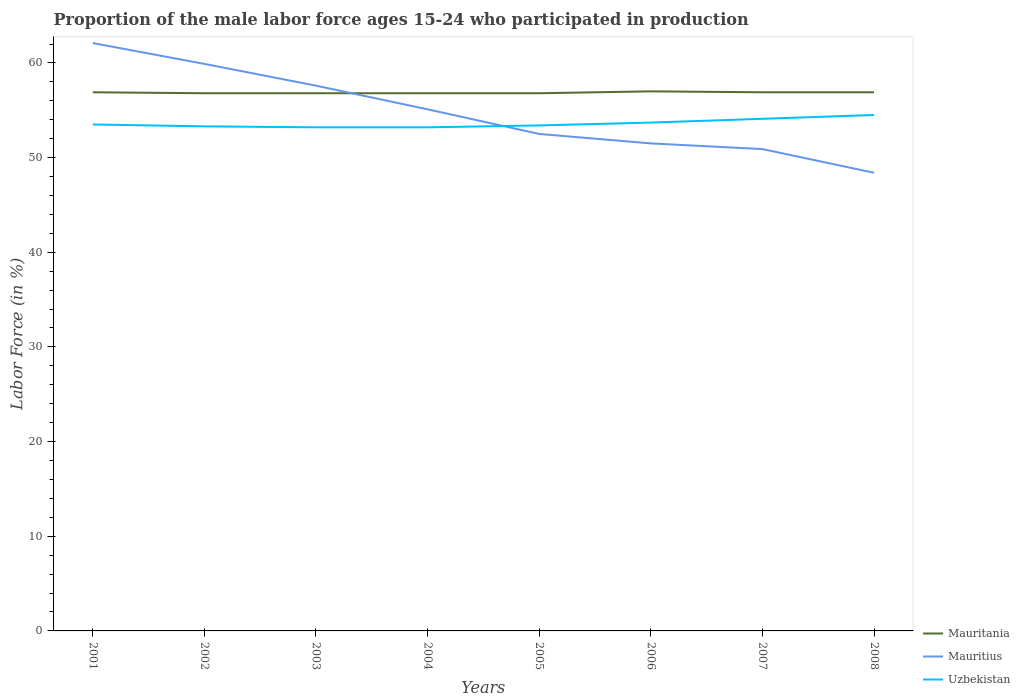How many different coloured lines are there?
Give a very brief answer. 3. Across all years, what is the maximum proportion of the male labor force who participated in production in Mauritania?
Your response must be concise. 56.8. What is the difference between the highest and the second highest proportion of the male labor force who participated in production in Mauritius?
Your answer should be compact. 13.7. How many years are there in the graph?
Give a very brief answer. 8. What is the difference between two consecutive major ticks on the Y-axis?
Offer a terse response. 10. Are the values on the major ticks of Y-axis written in scientific E-notation?
Your response must be concise. No. Does the graph contain any zero values?
Ensure brevity in your answer.  No. Where does the legend appear in the graph?
Keep it short and to the point. Bottom right. What is the title of the graph?
Provide a short and direct response. Proportion of the male labor force ages 15-24 who participated in production. Does "Liechtenstein" appear as one of the legend labels in the graph?
Offer a terse response. No. What is the label or title of the Y-axis?
Ensure brevity in your answer.  Labor Force (in %). What is the Labor Force (in %) of Mauritania in 2001?
Give a very brief answer. 56.9. What is the Labor Force (in %) of Mauritius in 2001?
Give a very brief answer. 62.1. What is the Labor Force (in %) in Uzbekistan in 2001?
Give a very brief answer. 53.5. What is the Labor Force (in %) of Mauritania in 2002?
Provide a succinct answer. 56.8. What is the Labor Force (in %) in Mauritius in 2002?
Your answer should be very brief. 59.9. What is the Labor Force (in %) of Uzbekistan in 2002?
Your answer should be compact. 53.3. What is the Labor Force (in %) of Mauritania in 2003?
Provide a short and direct response. 56.8. What is the Labor Force (in %) in Mauritius in 2003?
Your answer should be very brief. 57.6. What is the Labor Force (in %) of Uzbekistan in 2003?
Offer a terse response. 53.2. What is the Labor Force (in %) in Mauritania in 2004?
Provide a succinct answer. 56.8. What is the Labor Force (in %) of Mauritius in 2004?
Provide a short and direct response. 55.1. What is the Labor Force (in %) in Uzbekistan in 2004?
Your answer should be very brief. 53.2. What is the Labor Force (in %) in Mauritania in 2005?
Give a very brief answer. 56.8. What is the Labor Force (in %) of Mauritius in 2005?
Keep it short and to the point. 52.5. What is the Labor Force (in %) in Uzbekistan in 2005?
Give a very brief answer. 53.4. What is the Labor Force (in %) of Mauritania in 2006?
Ensure brevity in your answer.  57. What is the Labor Force (in %) in Mauritius in 2006?
Provide a succinct answer. 51.5. What is the Labor Force (in %) of Uzbekistan in 2006?
Ensure brevity in your answer.  53.7. What is the Labor Force (in %) of Mauritania in 2007?
Your answer should be very brief. 56.9. What is the Labor Force (in %) of Mauritius in 2007?
Keep it short and to the point. 50.9. What is the Labor Force (in %) in Uzbekistan in 2007?
Provide a succinct answer. 54.1. What is the Labor Force (in %) in Mauritania in 2008?
Offer a terse response. 56.9. What is the Labor Force (in %) in Mauritius in 2008?
Ensure brevity in your answer.  48.4. What is the Labor Force (in %) of Uzbekistan in 2008?
Provide a short and direct response. 54.5. Across all years, what is the maximum Labor Force (in %) of Mauritania?
Offer a very short reply. 57. Across all years, what is the maximum Labor Force (in %) of Mauritius?
Offer a terse response. 62.1. Across all years, what is the maximum Labor Force (in %) of Uzbekistan?
Keep it short and to the point. 54.5. Across all years, what is the minimum Labor Force (in %) in Mauritania?
Ensure brevity in your answer.  56.8. Across all years, what is the minimum Labor Force (in %) in Mauritius?
Your answer should be compact. 48.4. Across all years, what is the minimum Labor Force (in %) of Uzbekistan?
Provide a succinct answer. 53.2. What is the total Labor Force (in %) in Mauritania in the graph?
Provide a short and direct response. 454.9. What is the total Labor Force (in %) of Mauritius in the graph?
Offer a terse response. 438. What is the total Labor Force (in %) in Uzbekistan in the graph?
Your answer should be very brief. 428.9. What is the difference between the Labor Force (in %) of Mauritania in 2001 and that in 2002?
Your response must be concise. 0.1. What is the difference between the Labor Force (in %) in Mauritius in 2001 and that in 2002?
Offer a very short reply. 2.2. What is the difference between the Labor Force (in %) in Mauritania in 2001 and that in 2003?
Your response must be concise. 0.1. What is the difference between the Labor Force (in %) in Mauritius in 2001 and that in 2003?
Ensure brevity in your answer.  4.5. What is the difference between the Labor Force (in %) of Mauritania in 2001 and that in 2004?
Your answer should be very brief. 0.1. What is the difference between the Labor Force (in %) in Uzbekistan in 2001 and that in 2004?
Give a very brief answer. 0.3. What is the difference between the Labor Force (in %) of Mauritius in 2001 and that in 2006?
Provide a short and direct response. 10.6. What is the difference between the Labor Force (in %) of Mauritania in 2001 and that in 2007?
Offer a very short reply. 0. What is the difference between the Labor Force (in %) of Mauritania in 2001 and that in 2008?
Offer a very short reply. 0. What is the difference between the Labor Force (in %) in Uzbekistan in 2001 and that in 2008?
Your response must be concise. -1. What is the difference between the Labor Force (in %) of Mauritania in 2002 and that in 2003?
Ensure brevity in your answer.  0. What is the difference between the Labor Force (in %) of Uzbekistan in 2002 and that in 2003?
Keep it short and to the point. 0.1. What is the difference between the Labor Force (in %) of Mauritius in 2002 and that in 2004?
Keep it short and to the point. 4.8. What is the difference between the Labor Force (in %) of Uzbekistan in 2002 and that in 2004?
Offer a very short reply. 0.1. What is the difference between the Labor Force (in %) in Mauritania in 2002 and that in 2006?
Your answer should be very brief. -0.2. What is the difference between the Labor Force (in %) of Mauritius in 2002 and that in 2007?
Give a very brief answer. 9. What is the difference between the Labor Force (in %) in Mauritania in 2002 and that in 2008?
Your answer should be very brief. -0.1. What is the difference between the Labor Force (in %) of Mauritius in 2002 and that in 2008?
Offer a very short reply. 11.5. What is the difference between the Labor Force (in %) of Uzbekistan in 2002 and that in 2008?
Your response must be concise. -1.2. What is the difference between the Labor Force (in %) in Mauritania in 2003 and that in 2005?
Keep it short and to the point. 0. What is the difference between the Labor Force (in %) in Mauritius in 2003 and that in 2005?
Provide a short and direct response. 5.1. What is the difference between the Labor Force (in %) of Uzbekistan in 2003 and that in 2005?
Your response must be concise. -0.2. What is the difference between the Labor Force (in %) in Mauritius in 2003 and that in 2006?
Give a very brief answer. 6.1. What is the difference between the Labor Force (in %) of Uzbekistan in 2003 and that in 2006?
Make the answer very short. -0.5. What is the difference between the Labor Force (in %) in Mauritania in 2003 and that in 2007?
Give a very brief answer. -0.1. What is the difference between the Labor Force (in %) in Uzbekistan in 2003 and that in 2007?
Make the answer very short. -0.9. What is the difference between the Labor Force (in %) in Mauritius in 2003 and that in 2008?
Make the answer very short. 9.2. What is the difference between the Labor Force (in %) of Uzbekistan in 2003 and that in 2008?
Keep it short and to the point. -1.3. What is the difference between the Labor Force (in %) of Mauritania in 2004 and that in 2006?
Your answer should be very brief. -0.2. What is the difference between the Labor Force (in %) of Mauritius in 2004 and that in 2006?
Keep it short and to the point. 3.6. What is the difference between the Labor Force (in %) of Uzbekistan in 2004 and that in 2006?
Make the answer very short. -0.5. What is the difference between the Labor Force (in %) of Mauritius in 2004 and that in 2007?
Offer a very short reply. 4.2. What is the difference between the Labor Force (in %) of Mauritania in 2004 and that in 2008?
Offer a very short reply. -0.1. What is the difference between the Labor Force (in %) in Uzbekistan in 2004 and that in 2008?
Your answer should be very brief. -1.3. What is the difference between the Labor Force (in %) in Mauritius in 2005 and that in 2006?
Make the answer very short. 1. What is the difference between the Labor Force (in %) of Uzbekistan in 2005 and that in 2006?
Offer a terse response. -0.3. What is the difference between the Labor Force (in %) of Mauritius in 2005 and that in 2007?
Provide a succinct answer. 1.6. What is the difference between the Labor Force (in %) of Uzbekistan in 2005 and that in 2007?
Your answer should be very brief. -0.7. What is the difference between the Labor Force (in %) of Mauritania in 2005 and that in 2008?
Keep it short and to the point. -0.1. What is the difference between the Labor Force (in %) of Uzbekistan in 2005 and that in 2008?
Make the answer very short. -1.1. What is the difference between the Labor Force (in %) of Mauritius in 2006 and that in 2007?
Offer a very short reply. 0.6. What is the difference between the Labor Force (in %) in Uzbekistan in 2006 and that in 2007?
Your answer should be compact. -0.4. What is the difference between the Labor Force (in %) in Mauritius in 2006 and that in 2008?
Your response must be concise. 3.1. What is the difference between the Labor Force (in %) of Mauritius in 2007 and that in 2008?
Your response must be concise. 2.5. What is the difference between the Labor Force (in %) of Uzbekistan in 2007 and that in 2008?
Provide a short and direct response. -0.4. What is the difference between the Labor Force (in %) in Mauritania in 2001 and the Labor Force (in %) in Mauritius in 2002?
Offer a terse response. -3. What is the difference between the Labor Force (in %) in Mauritania in 2001 and the Labor Force (in %) in Uzbekistan in 2003?
Make the answer very short. 3.7. What is the difference between the Labor Force (in %) in Mauritius in 2001 and the Labor Force (in %) in Uzbekistan in 2003?
Offer a terse response. 8.9. What is the difference between the Labor Force (in %) of Mauritania in 2001 and the Labor Force (in %) of Mauritius in 2004?
Make the answer very short. 1.8. What is the difference between the Labor Force (in %) of Mauritius in 2001 and the Labor Force (in %) of Uzbekistan in 2004?
Your response must be concise. 8.9. What is the difference between the Labor Force (in %) of Mauritania in 2001 and the Labor Force (in %) of Mauritius in 2005?
Give a very brief answer. 4.4. What is the difference between the Labor Force (in %) in Mauritius in 2001 and the Labor Force (in %) in Uzbekistan in 2005?
Make the answer very short. 8.7. What is the difference between the Labor Force (in %) of Mauritania in 2001 and the Labor Force (in %) of Mauritius in 2006?
Make the answer very short. 5.4. What is the difference between the Labor Force (in %) in Mauritania in 2001 and the Labor Force (in %) in Uzbekistan in 2006?
Your response must be concise. 3.2. What is the difference between the Labor Force (in %) of Mauritius in 2001 and the Labor Force (in %) of Uzbekistan in 2007?
Offer a terse response. 8. What is the difference between the Labor Force (in %) of Mauritania in 2001 and the Labor Force (in %) of Mauritius in 2008?
Keep it short and to the point. 8.5. What is the difference between the Labor Force (in %) in Mauritania in 2002 and the Labor Force (in %) in Mauritius in 2003?
Your response must be concise. -0.8. What is the difference between the Labor Force (in %) of Mauritania in 2002 and the Labor Force (in %) of Uzbekistan in 2003?
Provide a succinct answer. 3.6. What is the difference between the Labor Force (in %) of Mauritius in 2002 and the Labor Force (in %) of Uzbekistan in 2003?
Make the answer very short. 6.7. What is the difference between the Labor Force (in %) of Mauritania in 2002 and the Labor Force (in %) of Mauritius in 2004?
Your answer should be very brief. 1.7. What is the difference between the Labor Force (in %) of Mauritania in 2002 and the Labor Force (in %) of Mauritius in 2005?
Provide a succinct answer. 4.3. What is the difference between the Labor Force (in %) of Mauritania in 2002 and the Labor Force (in %) of Uzbekistan in 2005?
Your answer should be very brief. 3.4. What is the difference between the Labor Force (in %) of Mauritius in 2002 and the Labor Force (in %) of Uzbekistan in 2005?
Your response must be concise. 6.5. What is the difference between the Labor Force (in %) of Mauritania in 2002 and the Labor Force (in %) of Mauritius in 2006?
Provide a short and direct response. 5.3. What is the difference between the Labor Force (in %) of Mauritania in 2002 and the Labor Force (in %) of Uzbekistan in 2006?
Offer a very short reply. 3.1. What is the difference between the Labor Force (in %) in Mauritius in 2002 and the Labor Force (in %) in Uzbekistan in 2007?
Make the answer very short. 5.8. What is the difference between the Labor Force (in %) in Mauritania in 2002 and the Labor Force (in %) in Uzbekistan in 2008?
Ensure brevity in your answer.  2.3. What is the difference between the Labor Force (in %) in Mauritius in 2002 and the Labor Force (in %) in Uzbekistan in 2008?
Give a very brief answer. 5.4. What is the difference between the Labor Force (in %) of Mauritania in 2003 and the Labor Force (in %) of Mauritius in 2004?
Your answer should be very brief. 1.7. What is the difference between the Labor Force (in %) of Mauritania in 2003 and the Labor Force (in %) of Uzbekistan in 2004?
Make the answer very short. 3.6. What is the difference between the Labor Force (in %) in Mauritania in 2003 and the Labor Force (in %) in Uzbekistan in 2005?
Offer a very short reply. 3.4. What is the difference between the Labor Force (in %) in Mauritania in 2003 and the Labor Force (in %) in Uzbekistan in 2006?
Offer a terse response. 3.1. What is the difference between the Labor Force (in %) of Mauritius in 2003 and the Labor Force (in %) of Uzbekistan in 2006?
Ensure brevity in your answer.  3.9. What is the difference between the Labor Force (in %) in Mauritania in 2003 and the Labor Force (in %) in Mauritius in 2007?
Make the answer very short. 5.9. What is the difference between the Labor Force (in %) in Mauritania in 2003 and the Labor Force (in %) in Uzbekistan in 2007?
Your answer should be very brief. 2.7. What is the difference between the Labor Force (in %) in Mauritius in 2003 and the Labor Force (in %) in Uzbekistan in 2007?
Keep it short and to the point. 3.5. What is the difference between the Labor Force (in %) of Mauritania in 2003 and the Labor Force (in %) of Uzbekistan in 2008?
Provide a short and direct response. 2.3. What is the difference between the Labor Force (in %) of Mauritania in 2004 and the Labor Force (in %) of Mauritius in 2005?
Provide a succinct answer. 4.3. What is the difference between the Labor Force (in %) of Mauritania in 2004 and the Labor Force (in %) of Mauritius in 2006?
Offer a very short reply. 5.3. What is the difference between the Labor Force (in %) of Mauritius in 2004 and the Labor Force (in %) of Uzbekistan in 2006?
Make the answer very short. 1.4. What is the difference between the Labor Force (in %) in Mauritania in 2004 and the Labor Force (in %) in Mauritius in 2008?
Offer a very short reply. 8.4. What is the difference between the Labor Force (in %) in Mauritania in 2004 and the Labor Force (in %) in Uzbekistan in 2008?
Ensure brevity in your answer.  2.3. What is the difference between the Labor Force (in %) in Mauritius in 2004 and the Labor Force (in %) in Uzbekistan in 2008?
Keep it short and to the point. 0.6. What is the difference between the Labor Force (in %) in Mauritania in 2005 and the Labor Force (in %) in Mauritius in 2006?
Provide a short and direct response. 5.3. What is the difference between the Labor Force (in %) in Mauritania in 2005 and the Labor Force (in %) in Mauritius in 2007?
Give a very brief answer. 5.9. What is the difference between the Labor Force (in %) of Mauritius in 2005 and the Labor Force (in %) of Uzbekistan in 2007?
Keep it short and to the point. -1.6. What is the difference between the Labor Force (in %) in Mauritania in 2005 and the Labor Force (in %) in Mauritius in 2008?
Ensure brevity in your answer.  8.4. What is the difference between the Labor Force (in %) in Mauritius in 2005 and the Labor Force (in %) in Uzbekistan in 2008?
Provide a short and direct response. -2. What is the difference between the Labor Force (in %) in Mauritania in 2006 and the Labor Force (in %) in Mauritius in 2007?
Give a very brief answer. 6.1. What is the difference between the Labor Force (in %) of Mauritania in 2006 and the Labor Force (in %) of Uzbekistan in 2007?
Offer a terse response. 2.9. What is the difference between the Labor Force (in %) of Mauritius in 2006 and the Labor Force (in %) of Uzbekistan in 2007?
Give a very brief answer. -2.6. What is the difference between the Labor Force (in %) in Mauritania in 2006 and the Labor Force (in %) in Mauritius in 2008?
Offer a very short reply. 8.6. What is the difference between the Labor Force (in %) in Mauritania in 2006 and the Labor Force (in %) in Uzbekistan in 2008?
Keep it short and to the point. 2.5. What is the difference between the Labor Force (in %) of Mauritius in 2006 and the Labor Force (in %) of Uzbekistan in 2008?
Your answer should be very brief. -3. What is the difference between the Labor Force (in %) of Mauritania in 2007 and the Labor Force (in %) of Uzbekistan in 2008?
Provide a succinct answer. 2.4. What is the difference between the Labor Force (in %) in Mauritius in 2007 and the Labor Force (in %) in Uzbekistan in 2008?
Your response must be concise. -3.6. What is the average Labor Force (in %) in Mauritania per year?
Your answer should be compact. 56.86. What is the average Labor Force (in %) in Mauritius per year?
Offer a very short reply. 54.75. What is the average Labor Force (in %) in Uzbekistan per year?
Ensure brevity in your answer.  53.61. In the year 2001, what is the difference between the Labor Force (in %) of Mauritania and Labor Force (in %) of Mauritius?
Keep it short and to the point. -5.2. In the year 2001, what is the difference between the Labor Force (in %) of Mauritania and Labor Force (in %) of Uzbekistan?
Offer a terse response. 3.4. In the year 2001, what is the difference between the Labor Force (in %) of Mauritius and Labor Force (in %) of Uzbekistan?
Give a very brief answer. 8.6. In the year 2002, what is the difference between the Labor Force (in %) of Mauritania and Labor Force (in %) of Mauritius?
Your answer should be very brief. -3.1. In the year 2002, what is the difference between the Labor Force (in %) in Mauritania and Labor Force (in %) in Uzbekistan?
Ensure brevity in your answer.  3.5. In the year 2003, what is the difference between the Labor Force (in %) in Mauritania and Labor Force (in %) in Mauritius?
Keep it short and to the point. -0.8. In the year 2003, what is the difference between the Labor Force (in %) in Mauritania and Labor Force (in %) in Uzbekistan?
Ensure brevity in your answer.  3.6. In the year 2003, what is the difference between the Labor Force (in %) of Mauritius and Labor Force (in %) of Uzbekistan?
Your response must be concise. 4.4. In the year 2004, what is the difference between the Labor Force (in %) in Mauritania and Labor Force (in %) in Mauritius?
Provide a short and direct response. 1.7. In the year 2004, what is the difference between the Labor Force (in %) in Mauritania and Labor Force (in %) in Uzbekistan?
Make the answer very short. 3.6. In the year 2004, what is the difference between the Labor Force (in %) in Mauritius and Labor Force (in %) in Uzbekistan?
Give a very brief answer. 1.9. In the year 2006, what is the difference between the Labor Force (in %) in Mauritius and Labor Force (in %) in Uzbekistan?
Offer a very short reply. -2.2. In the year 2007, what is the difference between the Labor Force (in %) of Mauritania and Labor Force (in %) of Uzbekistan?
Keep it short and to the point. 2.8. What is the ratio of the Labor Force (in %) in Mauritania in 2001 to that in 2002?
Keep it short and to the point. 1. What is the ratio of the Labor Force (in %) of Mauritius in 2001 to that in 2002?
Provide a short and direct response. 1.04. What is the ratio of the Labor Force (in %) in Mauritius in 2001 to that in 2003?
Make the answer very short. 1.08. What is the ratio of the Labor Force (in %) in Uzbekistan in 2001 to that in 2003?
Provide a short and direct response. 1.01. What is the ratio of the Labor Force (in %) of Mauritania in 2001 to that in 2004?
Offer a terse response. 1. What is the ratio of the Labor Force (in %) in Mauritius in 2001 to that in 2004?
Provide a short and direct response. 1.13. What is the ratio of the Labor Force (in %) of Uzbekistan in 2001 to that in 2004?
Your answer should be very brief. 1.01. What is the ratio of the Labor Force (in %) of Mauritania in 2001 to that in 2005?
Provide a succinct answer. 1. What is the ratio of the Labor Force (in %) in Mauritius in 2001 to that in 2005?
Make the answer very short. 1.18. What is the ratio of the Labor Force (in %) in Mauritania in 2001 to that in 2006?
Your response must be concise. 1. What is the ratio of the Labor Force (in %) of Mauritius in 2001 to that in 2006?
Give a very brief answer. 1.21. What is the ratio of the Labor Force (in %) in Uzbekistan in 2001 to that in 2006?
Offer a very short reply. 1. What is the ratio of the Labor Force (in %) of Mauritius in 2001 to that in 2007?
Keep it short and to the point. 1.22. What is the ratio of the Labor Force (in %) in Uzbekistan in 2001 to that in 2007?
Offer a terse response. 0.99. What is the ratio of the Labor Force (in %) of Mauritania in 2001 to that in 2008?
Offer a very short reply. 1. What is the ratio of the Labor Force (in %) in Mauritius in 2001 to that in 2008?
Keep it short and to the point. 1.28. What is the ratio of the Labor Force (in %) of Uzbekistan in 2001 to that in 2008?
Ensure brevity in your answer.  0.98. What is the ratio of the Labor Force (in %) of Mauritania in 2002 to that in 2003?
Your response must be concise. 1. What is the ratio of the Labor Force (in %) of Mauritius in 2002 to that in 2003?
Ensure brevity in your answer.  1.04. What is the ratio of the Labor Force (in %) in Uzbekistan in 2002 to that in 2003?
Your response must be concise. 1. What is the ratio of the Labor Force (in %) in Mauritius in 2002 to that in 2004?
Give a very brief answer. 1.09. What is the ratio of the Labor Force (in %) in Uzbekistan in 2002 to that in 2004?
Your response must be concise. 1. What is the ratio of the Labor Force (in %) of Mauritius in 2002 to that in 2005?
Provide a short and direct response. 1.14. What is the ratio of the Labor Force (in %) of Mauritius in 2002 to that in 2006?
Provide a succinct answer. 1.16. What is the ratio of the Labor Force (in %) of Mauritius in 2002 to that in 2007?
Provide a short and direct response. 1.18. What is the ratio of the Labor Force (in %) of Uzbekistan in 2002 to that in 2007?
Make the answer very short. 0.99. What is the ratio of the Labor Force (in %) of Mauritius in 2002 to that in 2008?
Make the answer very short. 1.24. What is the ratio of the Labor Force (in %) of Uzbekistan in 2002 to that in 2008?
Offer a very short reply. 0.98. What is the ratio of the Labor Force (in %) of Mauritania in 2003 to that in 2004?
Offer a very short reply. 1. What is the ratio of the Labor Force (in %) in Mauritius in 2003 to that in 2004?
Offer a terse response. 1.05. What is the ratio of the Labor Force (in %) of Mauritius in 2003 to that in 2005?
Give a very brief answer. 1.1. What is the ratio of the Labor Force (in %) in Uzbekistan in 2003 to that in 2005?
Offer a terse response. 1. What is the ratio of the Labor Force (in %) of Mauritania in 2003 to that in 2006?
Provide a succinct answer. 1. What is the ratio of the Labor Force (in %) in Mauritius in 2003 to that in 2006?
Offer a very short reply. 1.12. What is the ratio of the Labor Force (in %) in Uzbekistan in 2003 to that in 2006?
Your answer should be very brief. 0.99. What is the ratio of the Labor Force (in %) in Mauritania in 2003 to that in 2007?
Offer a very short reply. 1. What is the ratio of the Labor Force (in %) in Mauritius in 2003 to that in 2007?
Make the answer very short. 1.13. What is the ratio of the Labor Force (in %) of Uzbekistan in 2003 to that in 2007?
Your response must be concise. 0.98. What is the ratio of the Labor Force (in %) in Mauritius in 2003 to that in 2008?
Provide a succinct answer. 1.19. What is the ratio of the Labor Force (in %) of Uzbekistan in 2003 to that in 2008?
Ensure brevity in your answer.  0.98. What is the ratio of the Labor Force (in %) in Mauritania in 2004 to that in 2005?
Your answer should be compact. 1. What is the ratio of the Labor Force (in %) in Mauritius in 2004 to that in 2005?
Your response must be concise. 1.05. What is the ratio of the Labor Force (in %) of Uzbekistan in 2004 to that in 2005?
Ensure brevity in your answer.  1. What is the ratio of the Labor Force (in %) of Mauritius in 2004 to that in 2006?
Make the answer very short. 1.07. What is the ratio of the Labor Force (in %) of Uzbekistan in 2004 to that in 2006?
Offer a very short reply. 0.99. What is the ratio of the Labor Force (in %) of Mauritius in 2004 to that in 2007?
Your answer should be compact. 1.08. What is the ratio of the Labor Force (in %) in Uzbekistan in 2004 to that in 2007?
Your answer should be very brief. 0.98. What is the ratio of the Labor Force (in %) in Mauritania in 2004 to that in 2008?
Provide a succinct answer. 1. What is the ratio of the Labor Force (in %) in Mauritius in 2004 to that in 2008?
Make the answer very short. 1.14. What is the ratio of the Labor Force (in %) of Uzbekistan in 2004 to that in 2008?
Your answer should be very brief. 0.98. What is the ratio of the Labor Force (in %) of Mauritania in 2005 to that in 2006?
Your response must be concise. 1. What is the ratio of the Labor Force (in %) in Mauritius in 2005 to that in 2006?
Provide a short and direct response. 1.02. What is the ratio of the Labor Force (in %) in Uzbekistan in 2005 to that in 2006?
Make the answer very short. 0.99. What is the ratio of the Labor Force (in %) in Mauritania in 2005 to that in 2007?
Keep it short and to the point. 1. What is the ratio of the Labor Force (in %) of Mauritius in 2005 to that in 2007?
Offer a very short reply. 1.03. What is the ratio of the Labor Force (in %) of Uzbekistan in 2005 to that in 2007?
Make the answer very short. 0.99. What is the ratio of the Labor Force (in %) of Mauritania in 2005 to that in 2008?
Keep it short and to the point. 1. What is the ratio of the Labor Force (in %) in Mauritius in 2005 to that in 2008?
Your answer should be very brief. 1.08. What is the ratio of the Labor Force (in %) of Uzbekistan in 2005 to that in 2008?
Offer a very short reply. 0.98. What is the ratio of the Labor Force (in %) of Mauritius in 2006 to that in 2007?
Ensure brevity in your answer.  1.01. What is the ratio of the Labor Force (in %) in Mauritania in 2006 to that in 2008?
Your answer should be compact. 1. What is the ratio of the Labor Force (in %) in Mauritius in 2006 to that in 2008?
Make the answer very short. 1.06. What is the ratio of the Labor Force (in %) in Uzbekistan in 2006 to that in 2008?
Your answer should be compact. 0.99. What is the ratio of the Labor Force (in %) of Mauritania in 2007 to that in 2008?
Provide a short and direct response. 1. What is the ratio of the Labor Force (in %) of Mauritius in 2007 to that in 2008?
Offer a very short reply. 1.05. What is the difference between the highest and the second highest Labor Force (in %) in Uzbekistan?
Your response must be concise. 0.4. What is the difference between the highest and the lowest Labor Force (in %) in Mauritania?
Give a very brief answer. 0.2. What is the difference between the highest and the lowest Labor Force (in %) in Mauritius?
Provide a short and direct response. 13.7. What is the difference between the highest and the lowest Labor Force (in %) of Uzbekistan?
Offer a very short reply. 1.3. 